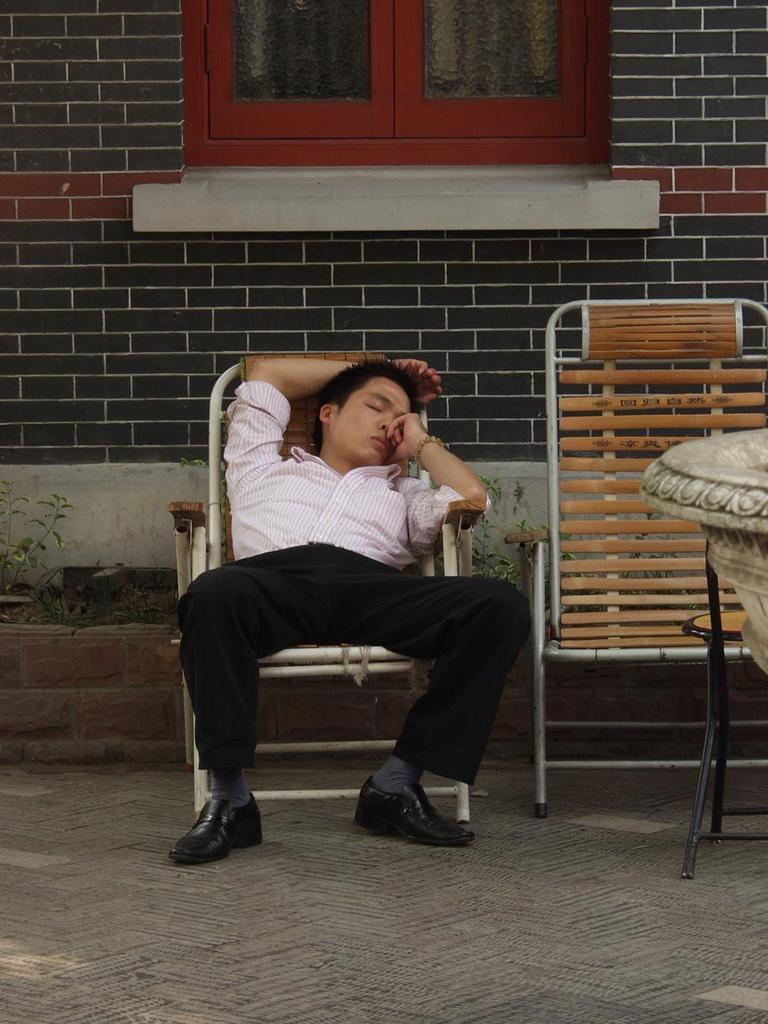In one or two sentences, can you explain what this image depicts? In the image there is a man sleeping in a chair and beside him there is an empty chair, in the background there is a wall and there is a window in between the wall. 